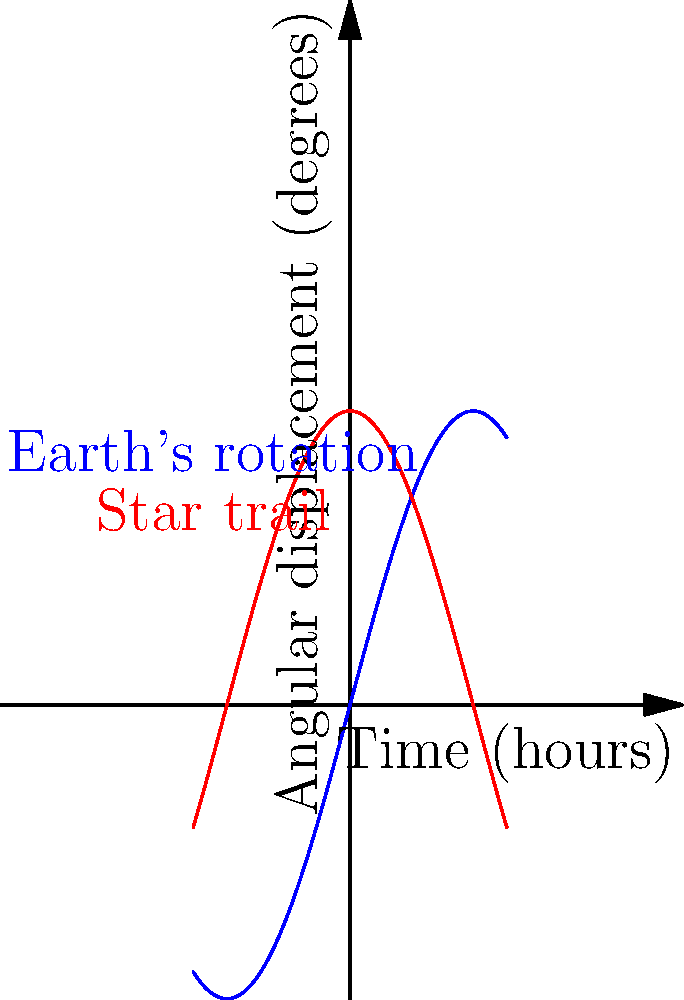As an astrophotographer, you're capturing star trails using long exposure techniques. Given that Earth rotates 15 degrees per hour, calculate the angular displacement of a star trail in your photograph if the exposure time is 2.5 hours. Additionally, explain how this would affect the composition of your experimental art piece that combines painting and astrophotography. To solve this problem, we'll follow these steps:

1. Understand the given information:
   - Earth rotates 15 degrees per hour
   - Exposure time is 2.5 hours

2. Calculate the angular displacement:
   - Angular displacement = Rotation rate × Time
   - Angular displacement = $15^\circ/\text{hour} \times 2.5 \text{ hours}$
   - Angular displacement = $37.5^\circ$

3. Artistic interpretation:
   The angular displacement of $37.5^\circ$ would create a significant arc in the star trail. This arc would span approximately 1/10th of a full circle (as a full circle is $360^\circ$). 

   In terms of the experimental art piece:
   - The star trails would create curved lines of light in the photograph.
   - These curves could be used as a base or inspiration for painted elements.
   - The length and curvature of the trails could be emphasized or contrasted with painted strokes.
   - The $37.5^\circ$ arc might be used as a recurring motif in the painted elements, creating a harmony between the photographic and painted components.
   - The direction of the arc could influence the overall composition, perhaps guiding the viewer's eye through the piece.

   This combination of precise astrophotography and interpretive painting could create a unique dialogue between scientific accuracy and artistic expression.
Answer: $37.5^\circ$ 